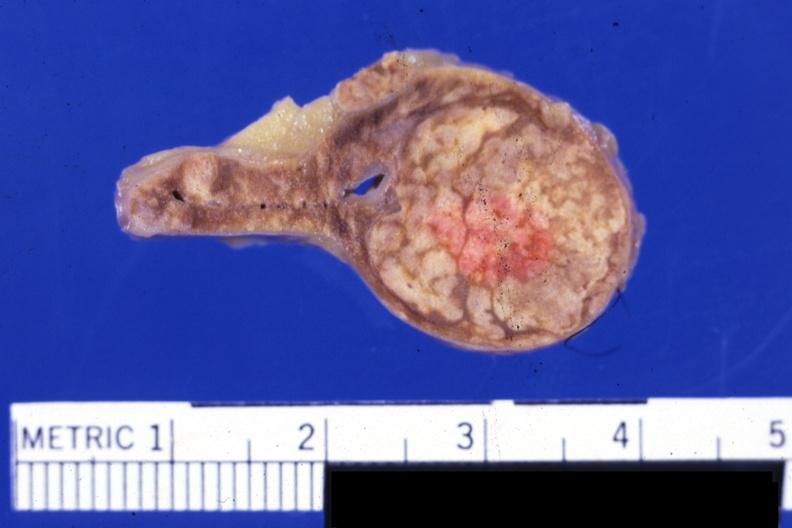does this image show fixed tissue but color not bad typical lesion?
Answer the question using a single word or phrase. Yes 